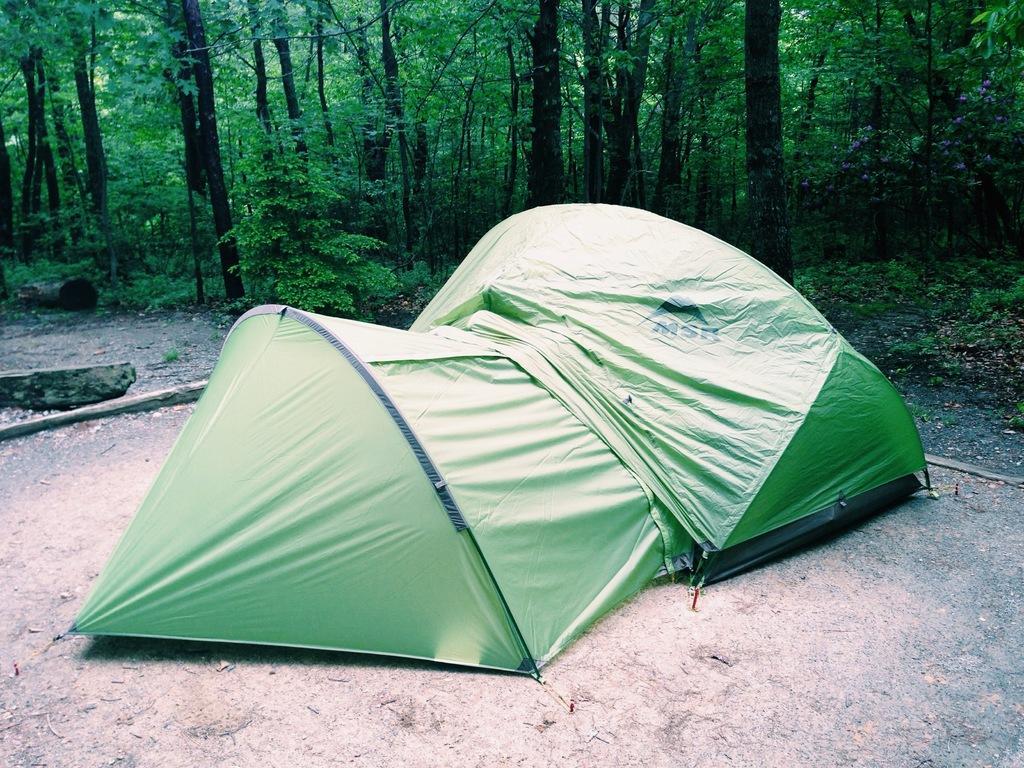Describe this image in one or two sentences. Here we can see green tent. Background there are plants and number of trees. 